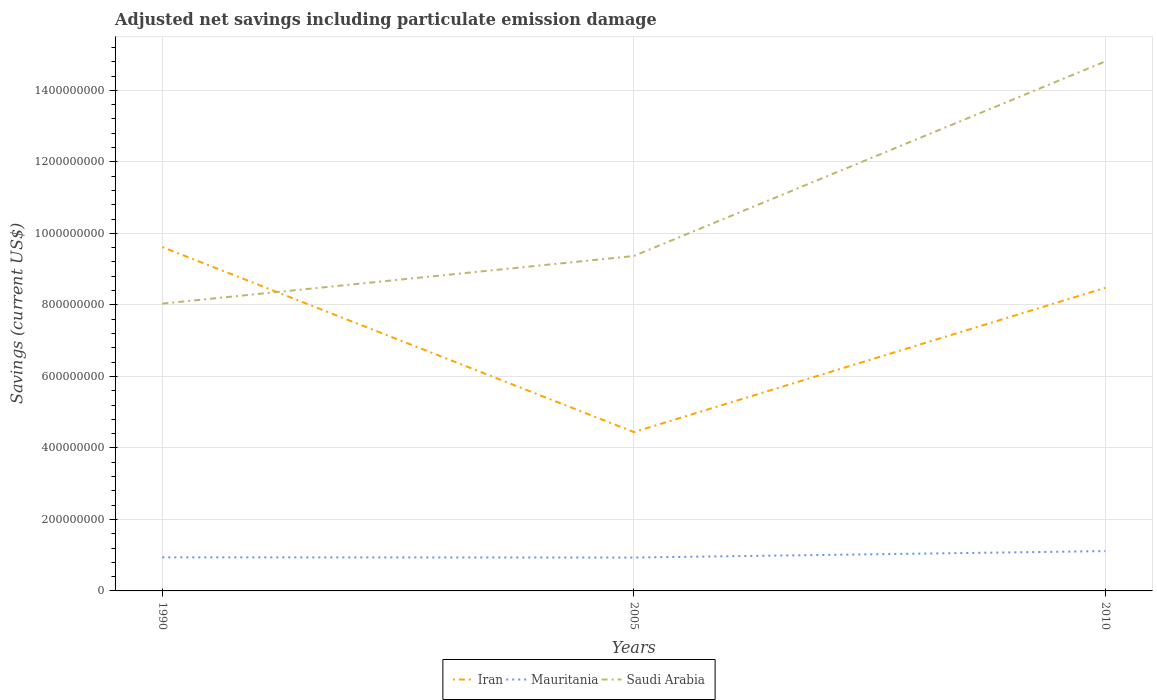Across all years, what is the maximum net savings in Saudi Arabia?
Your response must be concise. 8.04e+08. In which year was the net savings in Saudi Arabia maximum?
Your answer should be compact. 1990. What is the total net savings in Saudi Arabia in the graph?
Offer a terse response. -5.44e+08. What is the difference between the highest and the second highest net savings in Saudi Arabia?
Make the answer very short. 6.78e+08. How many lines are there?
Provide a succinct answer. 3. How many years are there in the graph?
Make the answer very short. 3. What is the difference between two consecutive major ticks on the Y-axis?
Make the answer very short. 2.00e+08. Are the values on the major ticks of Y-axis written in scientific E-notation?
Provide a short and direct response. No. Does the graph contain grids?
Ensure brevity in your answer.  Yes. Where does the legend appear in the graph?
Offer a very short reply. Bottom center. How many legend labels are there?
Give a very brief answer. 3. How are the legend labels stacked?
Provide a succinct answer. Horizontal. What is the title of the graph?
Offer a very short reply. Adjusted net savings including particulate emission damage. What is the label or title of the Y-axis?
Offer a terse response. Savings (current US$). What is the Savings (current US$) in Iran in 1990?
Ensure brevity in your answer.  9.62e+08. What is the Savings (current US$) of Mauritania in 1990?
Provide a succinct answer. 9.39e+07. What is the Savings (current US$) of Saudi Arabia in 1990?
Provide a succinct answer. 8.04e+08. What is the Savings (current US$) in Iran in 2005?
Your answer should be very brief. 4.44e+08. What is the Savings (current US$) of Mauritania in 2005?
Offer a terse response. 9.34e+07. What is the Savings (current US$) in Saudi Arabia in 2005?
Offer a terse response. 9.37e+08. What is the Savings (current US$) of Iran in 2010?
Your answer should be very brief. 8.48e+08. What is the Savings (current US$) in Mauritania in 2010?
Keep it short and to the point. 1.11e+08. What is the Savings (current US$) in Saudi Arabia in 2010?
Provide a short and direct response. 1.48e+09. Across all years, what is the maximum Savings (current US$) in Iran?
Provide a short and direct response. 9.62e+08. Across all years, what is the maximum Savings (current US$) in Mauritania?
Ensure brevity in your answer.  1.11e+08. Across all years, what is the maximum Savings (current US$) in Saudi Arabia?
Give a very brief answer. 1.48e+09. Across all years, what is the minimum Savings (current US$) of Iran?
Your answer should be very brief. 4.44e+08. Across all years, what is the minimum Savings (current US$) of Mauritania?
Your answer should be compact. 9.34e+07. Across all years, what is the minimum Savings (current US$) in Saudi Arabia?
Provide a short and direct response. 8.04e+08. What is the total Savings (current US$) of Iran in the graph?
Your answer should be very brief. 2.25e+09. What is the total Savings (current US$) in Mauritania in the graph?
Give a very brief answer. 2.99e+08. What is the total Savings (current US$) of Saudi Arabia in the graph?
Your answer should be very brief. 3.22e+09. What is the difference between the Savings (current US$) in Iran in 1990 and that in 2005?
Make the answer very short. 5.17e+08. What is the difference between the Savings (current US$) in Mauritania in 1990 and that in 2005?
Offer a very short reply. 5.18e+05. What is the difference between the Savings (current US$) of Saudi Arabia in 1990 and that in 2005?
Make the answer very short. -1.33e+08. What is the difference between the Savings (current US$) in Iran in 1990 and that in 2010?
Give a very brief answer. 1.14e+08. What is the difference between the Savings (current US$) in Mauritania in 1990 and that in 2010?
Provide a succinct answer. -1.74e+07. What is the difference between the Savings (current US$) of Saudi Arabia in 1990 and that in 2010?
Make the answer very short. -6.78e+08. What is the difference between the Savings (current US$) in Iran in 2005 and that in 2010?
Give a very brief answer. -4.04e+08. What is the difference between the Savings (current US$) of Mauritania in 2005 and that in 2010?
Provide a short and direct response. -1.80e+07. What is the difference between the Savings (current US$) in Saudi Arabia in 2005 and that in 2010?
Give a very brief answer. -5.44e+08. What is the difference between the Savings (current US$) in Iran in 1990 and the Savings (current US$) in Mauritania in 2005?
Offer a terse response. 8.68e+08. What is the difference between the Savings (current US$) of Iran in 1990 and the Savings (current US$) of Saudi Arabia in 2005?
Offer a terse response. 2.50e+07. What is the difference between the Savings (current US$) of Mauritania in 1990 and the Savings (current US$) of Saudi Arabia in 2005?
Your response must be concise. -8.43e+08. What is the difference between the Savings (current US$) in Iran in 1990 and the Savings (current US$) in Mauritania in 2010?
Ensure brevity in your answer.  8.50e+08. What is the difference between the Savings (current US$) in Iran in 1990 and the Savings (current US$) in Saudi Arabia in 2010?
Offer a terse response. -5.19e+08. What is the difference between the Savings (current US$) in Mauritania in 1990 and the Savings (current US$) in Saudi Arabia in 2010?
Ensure brevity in your answer.  -1.39e+09. What is the difference between the Savings (current US$) in Iran in 2005 and the Savings (current US$) in Mauritania in 2010?
Give a very brief answer. 3.33e+08. What is the difference between the Savings (current US$) of Iran in 2005 and the Savings (current US$) of Saudi Arabia in 2010?
Ensure brevity in your answer.  -1.04e+09. What is the difference between the Savings (current US$) in Mauritania in 2005 and the Savings (current US$) in Saudi Arabia in 2010?
Your answer should be compact. -1.39e+09. What is the average Savings (current US$) in Iran per year?
Offer a terse response. 7.51e+08. What is the average Savings (current US$) of Mauritania per year?
Keep it short and to the point. 9.96e+07. What is the average Savings (current US$) in Saudi Arabia per year?
Give a very brief answer. 1.07e+09. In the year 1990, what is the difference between the Savings (current US$) of Iran and Savings (current US$) of Mauritania?
Your response must be concise. 8.68e+08. In the year 1990, what is the difference between the Savings (current US$) in Iran and Savings (current US$) in Saudi Arabia?
Provide a short and direct response. 1.58e+08. In the year 1990, what is the difference between the Savings (current US$) in Mauritania and Savings (current US$) in Saudi Arabia?
Provide a succinct answer. -7.10e+08. In the year 2005, what is the difference between the Savings (current US$) in Iran and Savings (current US$) in Mauritania?
Provide a short and direct response. 3.51e+08. In the year 2005, what is the difference between the Savings (current US$) of Iran and Savings (current US$) of Saudi Arabia?
Your answer should be compact. -4.92e+08. In the year 2005, what is the difference between the Savings (current US$) in Mauritania and Savings (current US$) in Saudi Arabia?
Provide a short and direct response. -8.43e+08. In the year 2010, what is the difference between the Savings (current US$) in Iran and Savings (current US$) in Mauritania?
Your answer should be very brief. 7.36e+08. In the year 2010, what is the difference between the Savings (current US$) of Iran and Savings (current US$) of Saudi Arabia?
Provide a short and direct response. -6.33e+08. In the year 2010, what is the difference between the Savings (current US$) of Mauritania and Savings (current US$) of Saudi Arabia?
Your response must be concise. -1.37e+09. What is the ratio of the Savings (current US$) in Iran in 1990 to that in 2005?
Ensure brevity in your answer.  2.16. What is the ratio of the Savings (current US$) in Mauritania in 1990 to that in 2005?
Your answer should be very brief. 1.01. What is the ratio of the Savings (current US$) of Saudi Arabia in 1990 to that in 2005?
Give a very brief answer. 0.86. What is the ratio of the Savings (current US$) of Iran in 1990 to that in 2010?
Keep it short and to the point. 1.13. What is the ratio of the Savings (current US$) in Mauritania in 1990 to that in 2010?
Provide a succinct answer. 0.84. What is the ratio of the Savings (current US$) in Saudi Arabia in 1990 to that in 2010?
Ensure brevity in your answer.  0.54. What is the ratio of the Savings (current US$) of Iran in 2005 to that in 2010?
Your answer should be compact. 0.52. What is the ratio of the Savings (current US$) in Mauritania in 2005 to that in 2010?
Give a very brief answer. 0.84. What is the ratio of the Savings (current US$) of Saudi Arabia in 2005 to that in 2010?
Provide a succinct answer. 0.63. What is the difference between the highest and the second highest Savings (current US$) in Iran?
Your answer should be very brief. 1.14e+08. What is the difference between the highest and the second highest Savings (current US$) in Mauritania?
Offer a terse response. 1.74e+07. What is the difference between the highest and the second highest Savings (current US$) in Saudi Arabia?
Your response must be concise. 5.44e+08. What is the difference between the highest and the lowest Savings (current US$) in Iran?
Keep it short and to the point. 5.17e+08. What is the difference between the highest and the lowest Savings (current US$) of Mauritania?
Make the answer very short. 1.80e+07. What is the difference between the highest and the lowest Savings (current US$) of Saudi Arabia?
Make the answer very short. 6.78e+08. 